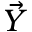<formula> <loc_0><loc_0><loc_500><loc_500>\vec { Y }</formula> 